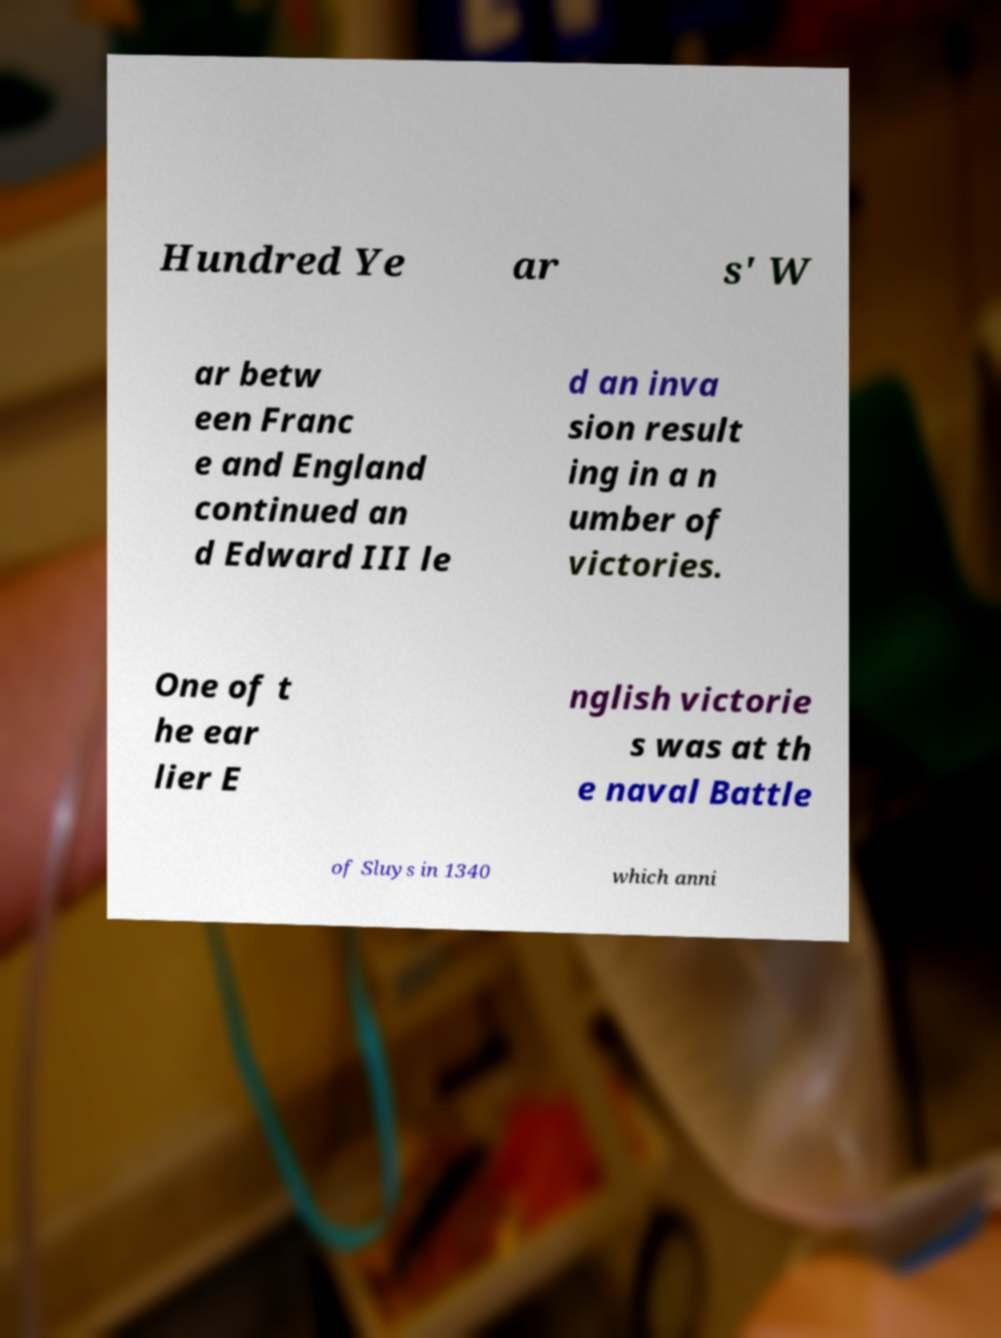There's text embedded in this image that I need extracted. Can you transcribe it verbatim? Hundred Ye ar s' W ar betw een Franc e and England continued an d Edward III le d an inva sion result ing in a n umber of victories. One of t he ear lier E nglish victorie s was at th e naval Battle of Sluys in 1340 which anni 